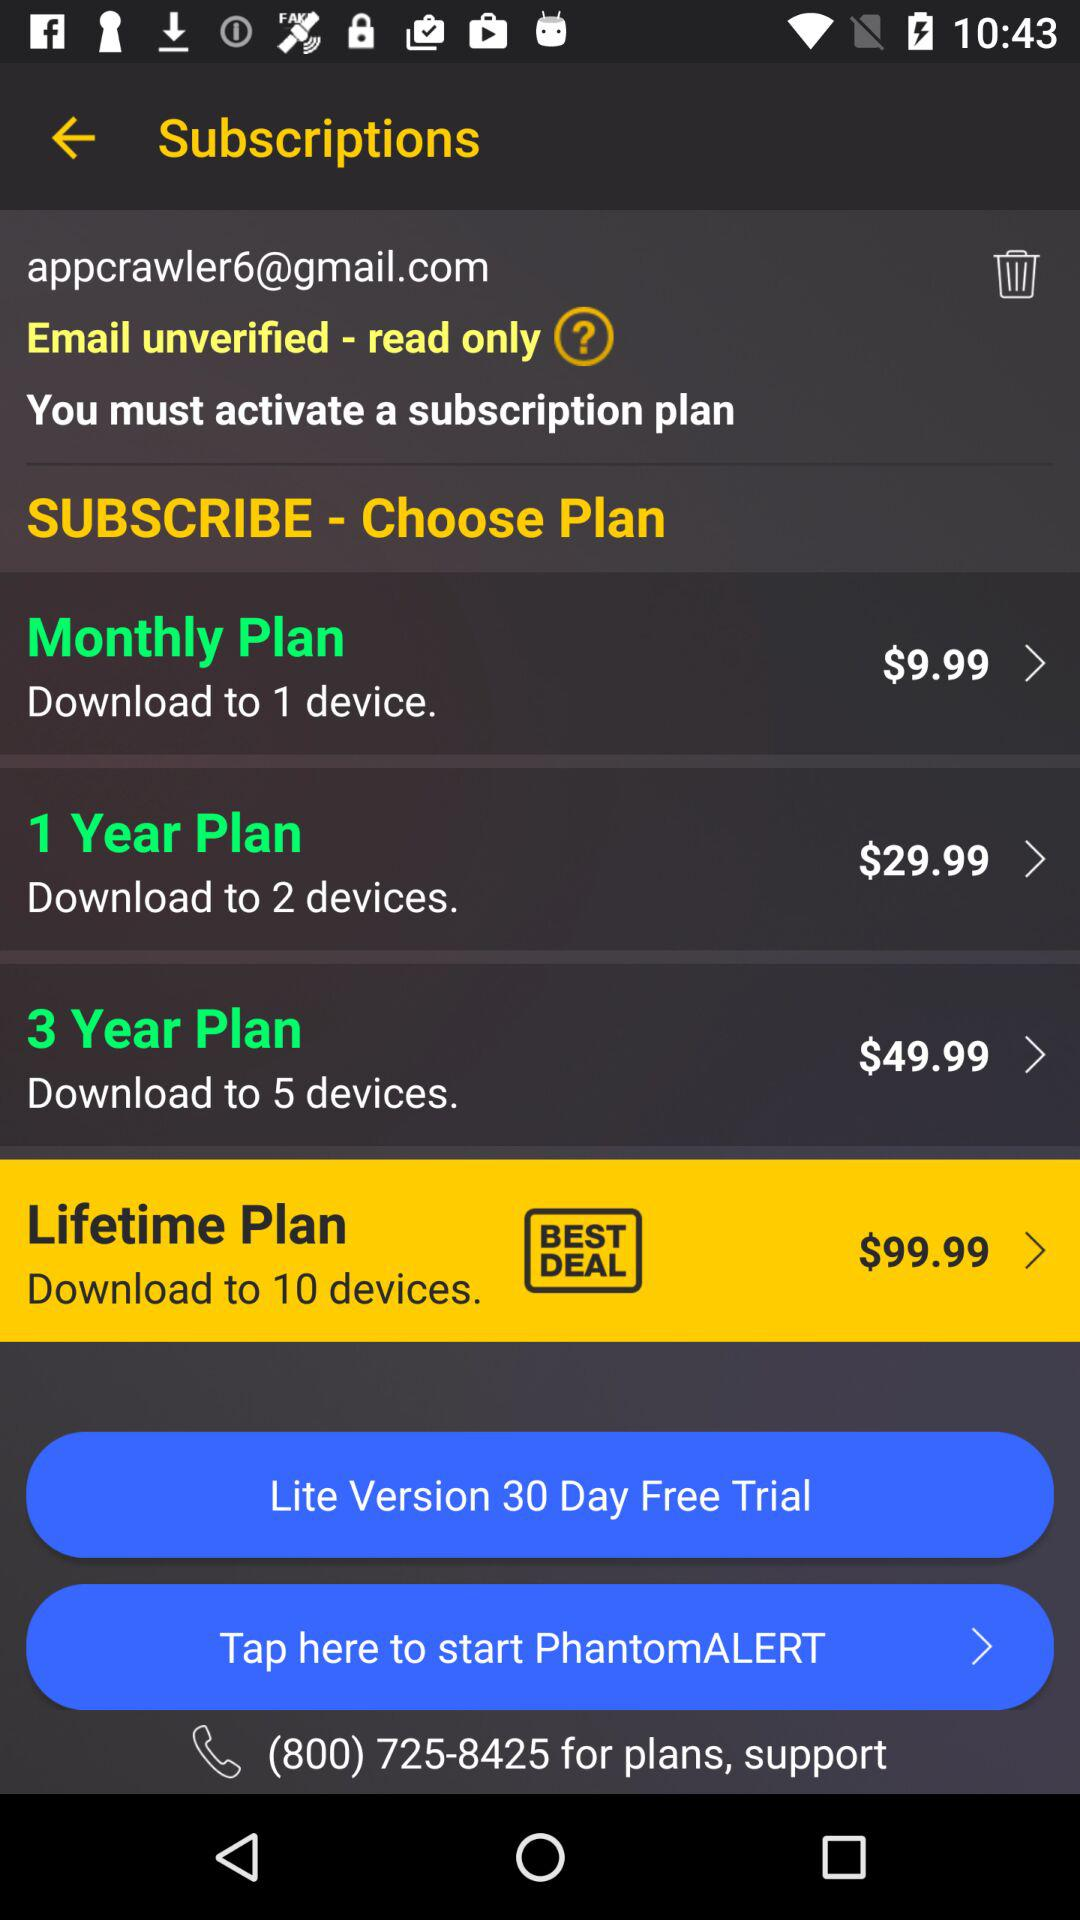What is the contact number provided for support? The contact number provided for support is (800) 725-8425. 